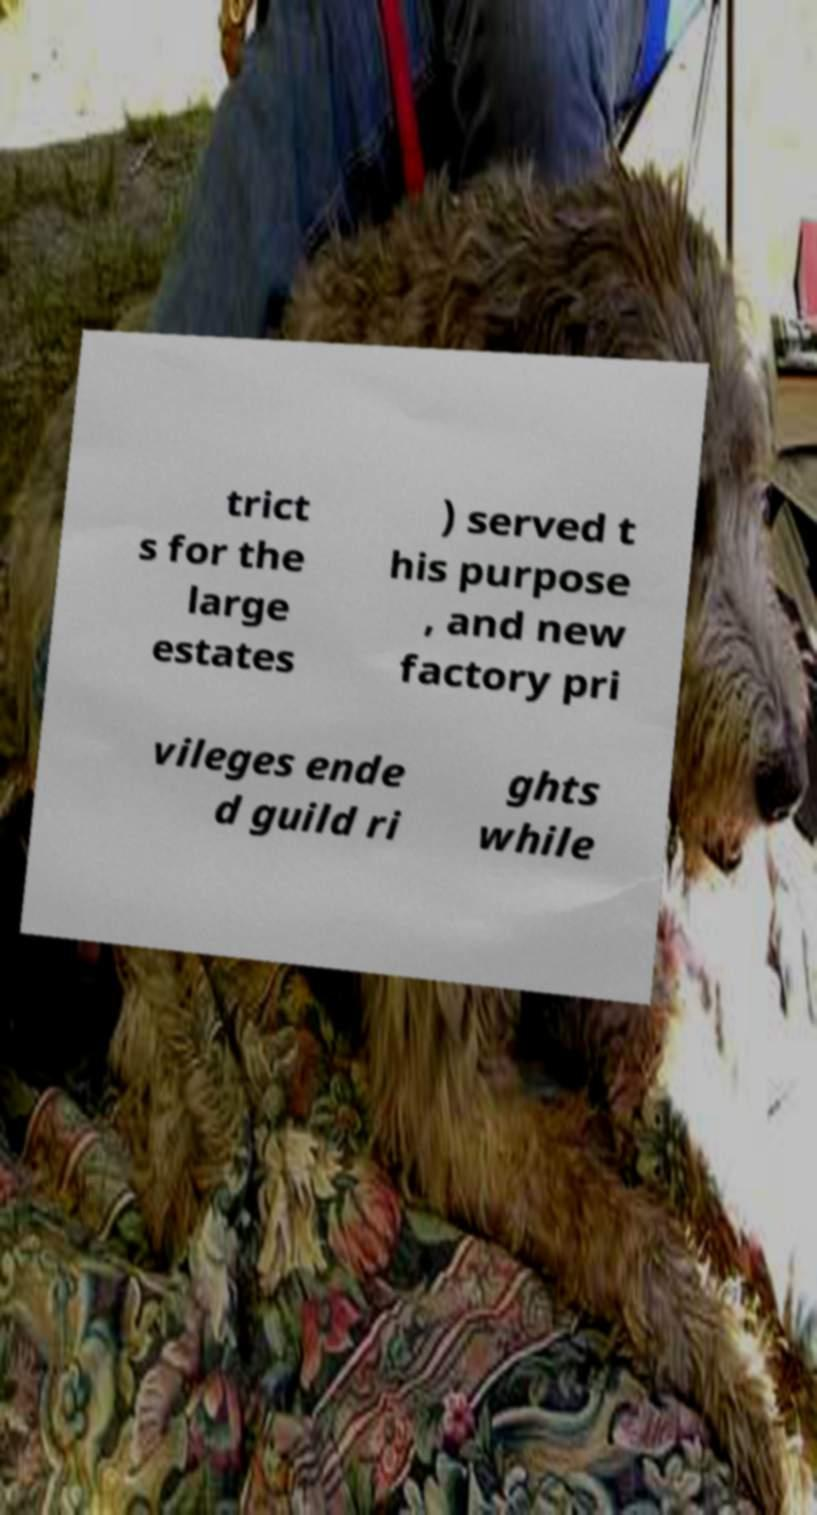Can you accurately transcribe the text from the provided image for me? trict s for the large estates ) served t his purpose , and new factory pri vileges ende d guild ri ghts while 